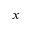Convert formula to latex. <formula><loc_0><loc_0><loc_500><loc_500>x</formula> 